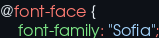<code> <loc_0><loc_0><loc_500><loc_500><_CSS_>@font-face {
    font-family: "Sofia";</code> 